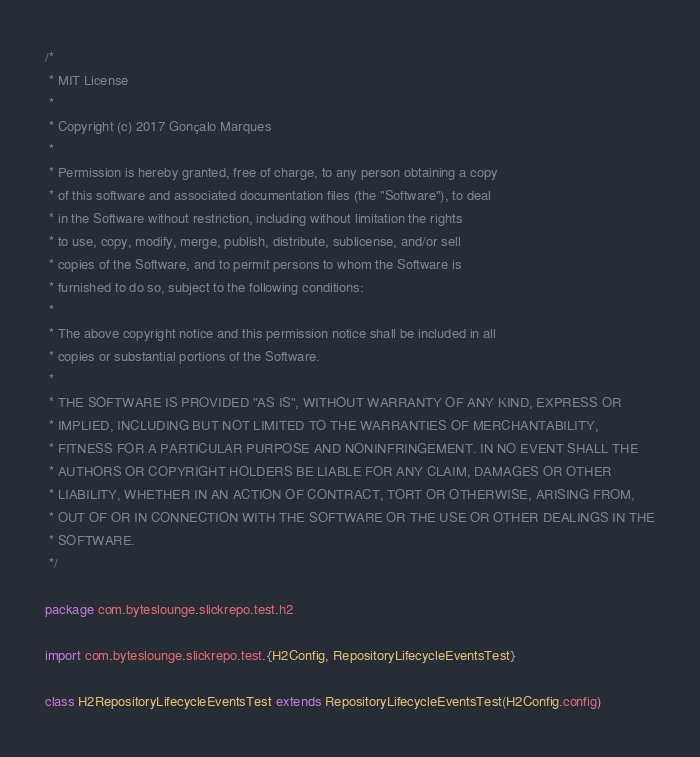<code> <loc_0><loc_0><loc_500><loc_500><_Scala_>/*
 * MIT License
 *
 * Copyright (c) 2017 Gonçalo Marques
 *
 * Permission is hereby granted, free of charge, to any person obtaining a copy
 * of this software and associated documentation files (the "Software"), to deal
 * in the Software without restriction, including without limitation the rights
 * to use, copy, modify, merge, publish, distribute, sublicense, and/or sell
 * copies of the Software, and to permit persons to whom the Software is
 * furnished to do so, subject to the following conditions:
 *
 * The above copyright notice and this permission notice shall be included in all
 * copies or substantial portions of the Software.
 *
 * THE SOFTWARE IS PROVIDED "AS IS", WITHOUT WARRANTY OF ANY KIND, EXPRESS OR
 * IMPLIED, INCLUDING BUT NOT LIMITED TO THE WARRANTIES OF MERCHANTABILITY,
 * FITNESS FOR A PARTICULAR PURPOSE AND NONINFRINGEMENT. IN NO EVENT SHALL THE
 * AUTHORS OR COPYRIGHT HOLDERS BE LIABLE FOR ANY CLAIM, DAMAGES OR OTHER
 * LIABILITY, WHETHER IN AN ACTION OF CONTRACT, TORT OR OTHERWISE, ARISING FROM,
 * OUT OF OR IN CONNECTION WITH THE SOFTWARE OR THE USE OR OTHER DEALINGS IN THE
 * SOFTWARE.
 */

package com.byteslounge.slickrepo.test.h2

import com.byteslounge.slickrepo.test.{H2Config, RepositoryLifecycleEventsTest}

class H2RepositoryLifecycleEventsTest extends RepositoryLifecycleEventsTest(H2Config.config)
</code> 